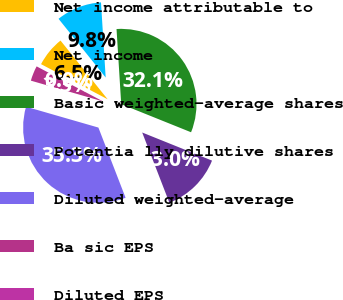Convert chart. <chart><loc_0><loc_0><loc_500><loc_500><pie_chart><fcel>Net income attributable to<fcel>Net income<fcel>Basic weighted-average shares<fcel>Potentia lly dilutive shares<fcel>Diluted weighted-average<fcel>Ba sic EPS<fcel>Diluted EPS<nl><fcel>6.51%<fcel>9.77%<fcel>32.08%<fcel>13.03%<fcel>35.34%<fcel>3.26%<fcel>0.0%<nl></chart> 